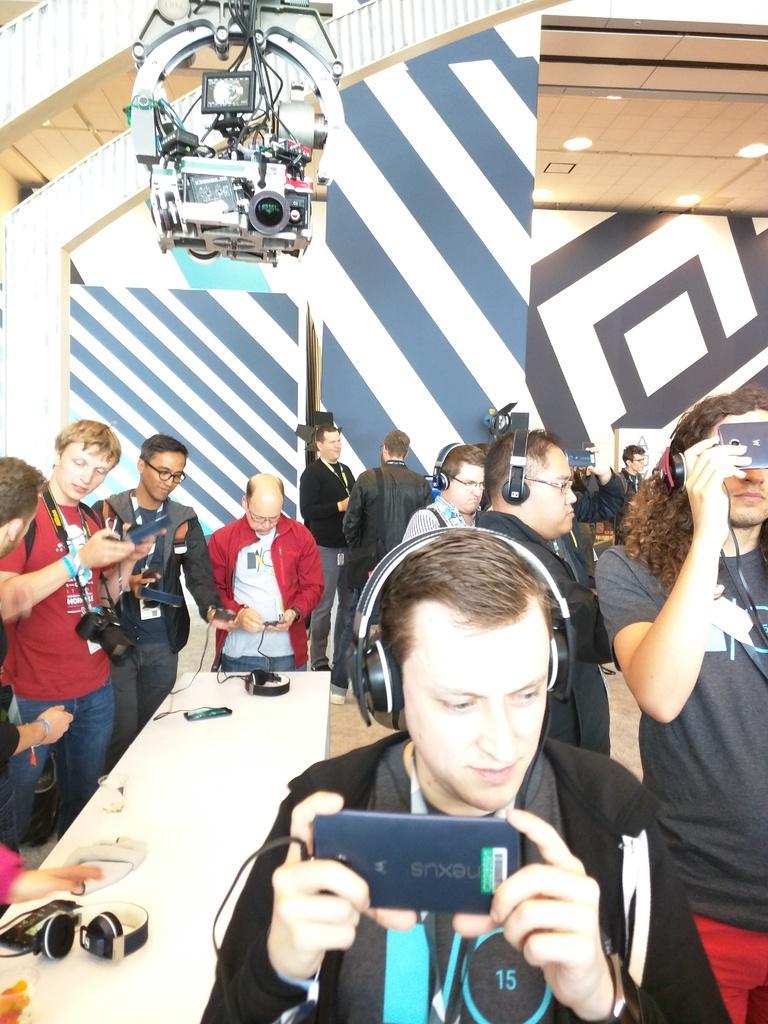Describe this image in one or two sentences. In this image there are group of people who are standing and they are wearing headsets and in the center there is one table. On the table there are some headsets and mobile phone is there. On the top there is one camera and wall is there and ceiling and on the ceiling there are some lights. 